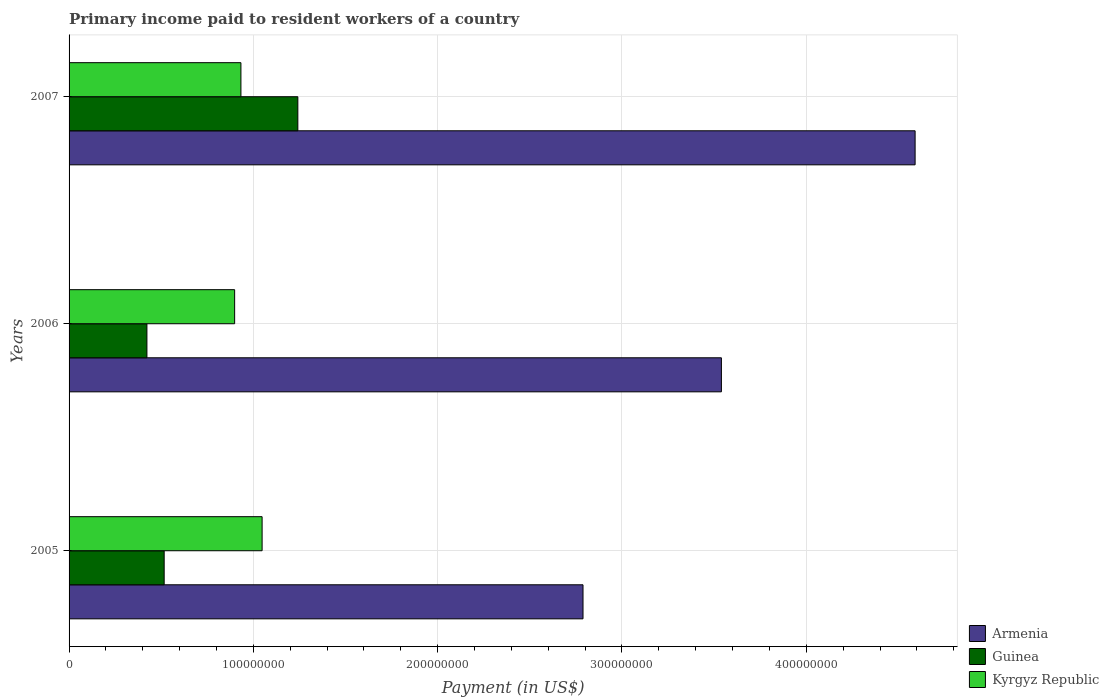How many groups of bars are there?
Offer a very short reply. 3. Are the number of bars per tick equal to the number of legend labels?
Give a very brief answer. Yes. Are the number of bars on each tick of the Y-axis equal?
Make the answer very short. Yes. How many bars are there on the 1st tick from the bottom?
Offer a very short reply. 3. In how many cases, is the number of bars for a given year not equal to the number of legend labels?
Provide a succinct answer. 0. What is the amount paid to workers in Guinea in 2005?
Offer a very short reply. 5.16e+07. Across all years, what is the maximum amount paid to workers in Armenia?
Offer a terse response. 4.59e+08. Across all years, what is the minimum amount paid to workers in Kyrgyz Republic?
Offer a very short reply. 8.98e+07. What is the total amount paid to workers in Guinea in the graph?
Offer a terse response. 2.18e+08. What is the difference between the amount paid to workers in Guinea in 2005 and that in 2006?
Offer a very short reply. 9.36e+06. What is the difference between the amount paid to workers in Armenia in 2006 and the amount paid to workers in Kyrgyz Republic in 2007?
Offer a terse response. 2.61e+08. What is the average amount paid to workers in Armenia per year?
Your response must be concise. 3.64e+08. In the year 2005, what is the difference between the amount paid to workers in Kyrgyz Republic and amount paid to workers in Armenia?
Your answer should be very brief. -1.74e+08. In how many years, is the amount paid to workers in Guinea greater than 160000000 US$?
Keep it short and to the point. 0. What is the ratio of the amount paid to workers in Guinea in 2005 to that in 2006?
Offer a very short reply. 1.22. Is the amount paid to workers in Kyrgyz Republic in 2005 less than that in 2006?
Keep it short and to the point. No. Is the difference between the amount paid to workers in Kyrgyz Republic in 2006 and 2007 greater than the difference between the amount paid to workers in Armenia in 2006 and 2007?
Offer a very short reply. Yes. What is the difference between the highest and the second highest amount paid to workers in Armenia?
Keep it short and to the point. 1.05e+08. What is the difference between the highest and the lowest amount paid to workers in Guinea?
Provide a short and direct response. 8.19e+07. Is the sum of the amount paid to workers in Armenia in 2005 and 2006 greater than the maximum amount paid to workers in Guinea across all years?
Offer a terse response. Yes. What does the 2nd bar from the top in 2007 represents?
Ensure brevity in your answer.  Guinea. What does the 1st bar from the bottom in 2005 represents?
Ensure brevity in your answer.  Armenia. Does the graph contain grids?
Offer a very short reply. Yes. What is the title of the graph?
Your answer should be very brief. Primary income paid to resident workers of a country. Does "Sierra Leone" appear as one of the legend labels in the graph?
Give a very brief answer. No. What is the label or title of the X-axis?
Provide a succinct answer. Payment (in US$). What is the label or title of the Y-axis?
Ensure brevity in your answer.  Years. What is the Payment (in US$) in Armenia in 2005?
Your answer should be very brief. 2.79e+08. What is the Payment (in US$) in Guinea in 2005?
Your response must be concise. 5.16e+07. What is the Payment (in US$) in Kyrgyz Republic in 2005?
Provide a succinct answer. 1.05e+08. What is the Payment (in US$) in Armenia in 2006?
Your answer should be compact. 3.54e+08. What is the Payment (in US$) of Guinea in 2006?
Offer a very short reply. 4.22e+07. What is the Payment (in US$) of Kyrgyz Republic in 2006?
Provide a short and direct response. 8.98e+07. What is the Payment (in US$) in Armenia in 2007?
Give a very brief answer. 4.59e+08. What is the Payment (in US$) in Guinea in 2007?
Your answer should be compact. 1.24e+08. What is the Payment (in US$) of Kyrgyz Republic in 2007?
Make the answer very short. 9.32e+07. Across all years, what is the maximum Payment (in US$) in Armenia?
Keep it short and to the point. 4.59e+08. Across all years, what is the maximum Payment (in US$) in Guinea?
Offer a terse response. 1.24e+08. Across all years, what is the maximum Payment (in US$) in Kyrgyz Republic?
Ensure brevity in your answer.  1.05e+08. Across all years, what is the minimum Payment (in US$) of Armenia?
Your answer should be compact. 2.79e+08. Across all years, what is the minimum Payment (in US$) of Guinea?
Your answer should be compact. 4.22e+07. Across all years, what is the minimum Payment (in US$) of Kyrgyz Republic?
Offer a terse response. 8.98e+07. What is the total Payment (in US$) in Armenia in the graph?
Keep it short and to the point. 1.09e+09. What is the total Payment (in US$) of Guinea in the graph?
Offer a terse response. 2.18e+08. What is the total Payment (in US$) in Kyrgyz Republic in the graph?
Offer a very short reply. 2.88e+08. What is the difference between the Payment (in US$) of Armenia in 2005 and that in 2006?
Your answer should be compact. -7.51e+07. What is the difference between the Payment (in US$) of Guinea in 2005 and that in 2006?
Give a very brief answer. 9.36e+06. What is the difference between the Payment (in US$) in Kyrgyz Republic in 2005 and that in 2006?
Give a very brief answer. 1.49e+07. What is the difference between the Payment (in US$) in Armenia in 2005 and that in 2007?
Provide a short and direct response. -1.80e+08. What is the difference between the Payment (in US$) of Guinea in 2005 and that in 2007?
Keep it short and to the point. -7.25e+07. What is the difference between the Payment (in US$) in Kyrgyz Republic in 2005 and that in 2007?
Keep it short and to the point. 1.15e+07. What is the difference between the Payment (in US$) of Armenia in 2006 and that in 2007?
Provide a succinct answer. -1.05e+08. What is the difference between the Payment (in US$) in Guinea in 2006 and that in 2007?
Offer a terse response. -8.19e+07. What is the difference between the Payment (in US$) in Kyrgyz Republic in 2006 and that in 2007?
Give a very brief answer. -3.41e+06. What is the difference between the Payment (in US$) in Armenia in 2005 and the Payment (in US$) in Guinea in 2006?
Your response must be concise. 2.37e+08. What is the difference between the Payment (in US$) of Armenia in 2005 and the Payment (in US$) of Kyrgyz Republic in 2006?
Keep it short and to the point. 1.89e+08. What is the difference between the Payment (in US$) in Guinea in 2005 and the Payment (in US$) in Kyrgyz Republic in 2006?
Your answer should be compact. -3.82e+07. What is the difference between the Payment (in US$) of Armenia in 2005 and the Payment (in US$) of Guinea in 2007?
Your answer should be compact. 1.55e+08. What is the difference between the Payment (in US$) of Armenia in 2005 and the Payment (in US$) of Kyrgyz Republic in 2007?
Make the answer very short. 1.86e+08. What is the difference between the Payment (in US$) of Guinea in 2005 and the Payment (in US$) of Kyrgyz Republic in 2007?
Offer a terse response. -4.16e+07. What is the difference between the Payment (in US$) of Armenia in 2006 and the Payment (in US$) of Guinea in 2007?
Keep it short and to the point. 2.30e+08. What is the difference between the Payment (in US$) of Armenia in 2006 and the Payment (in US$) of Kyrgyz Republic in 2007?
Ensure brevity in your answer.  2.61e+08. What is the difference between the Payment (in US$) of Guinea in 2006 and the Payment (in US$) of Kyrgyz Republic in 2007?
Give a very brief answer. -5.10e+07. What is the average Payment (in US$) of Armenia per year?
Give a very brief answer. 3.64e+08. What is the average Payment (in US$) in Guinea per year?
Give a very brief answer. 7.27e+07. What is the average Payment (in US$) in Kyrgyz Republic per year?
Your answer should be compact. 9.59e+07. In the year 2005, what is the difference between the Payment (in US$) of Armenia and Payment (in US$) of Guinea?
Provide a succinct answer. 2.27e+08. In the year 2005, what is the difference between the Payment (in US$) in Armenia and Payment (in US$) in Kyrgyz Republic?
Keep it short and to the point. 1.74e+08. In the year 2005, what is the difference between the Payment (in US$) in Guinea and Payment (in US$) in Kyrgyz Republic?
Offer a terse response. -5.31e+07. In the year 2006, what is the difference between the Payment (in US$) of Armenia and Payment (in US$) of Guinea?
Provide a succinct answer. 3.12e+08. In the year 2006, what is the difference between the Payment (in US$) of Armenia and Payment (in US$) of Kyrgyz Republic?
Offer a very short reply. 2.64e+08. In the year 2006, what is the difference between the Payment (in US$) of Guinea and Payment (in US$) of Kyrgyz Republic?
Provide a succinct answer. -4.76e+07. In the year 2007, what is the difference between the Payment (in US$) in Armenia and Payment (in US$) in Guinea?
Provide a short and direct response. 3.35e+08. In the year 2007, what is the difference between the Payment (in US$) of Armenia and Payment (in US$) of Kyrgyz Republic?
Your answer should be very brief. 3.66e+08. In the year 2007, what is the difference between the Payment (in US$) in Guinea and Payment (in US$) in Kyrgyz Republic?
Provide a short and direct response. 3.09e+07. What is the ratio of the Payment (in US$) of Armenia in 2005 to that in 2006?
Your answer should be very brief. 0.79. What is the ratio of the Payment (in US$) of Guinea in 2005 to that in 2006?
Provide a succinct answer. 1.22. What is the ratio of the Payment (in US$) in Kyrgyz Republic in 2005 to that in 2006?
Your response must be concise. 1.17. What is the ratio of the Payment (in US$) of Armenia in 2005 to that in 2007?
Provide a short and direct response. 0.61. What is the ratio of the Payment (in US$) in Guinea in 2005 to that in 2007?
Give a very brief answer. 0.42. What is the ratio of the Payment (in US$) of Kyrgyz Republic in 2005 to that in 2007?
Offer a terse response. 1.12. What is the ratio of the Payment (in US$) in Armenia in 2006 to that in 2007?
Keep it short and to the point. 0.77. What is the ratio of the Payment (in US$) of Guinea in 2006 to that in 2007?
Make the answer very short. 0.34. What is the ratio of the Payment (in US$) in Kyrgyz Republic in 2006 to that in 2007?
Give a very brief answer. 0.96. What is the difference between the highest and the second highest Payment (in US$) of Armenia?
Give a very brief answer. 1.05e+08. What is the difference between the highest and the second highest Payment (in US$) in Guinea?
Your answer should be very brief. 7.25e+07. What is the difference between the highest and the second highest Payment (in US$) of Kyrgyz Republic?
Provide a short and direct response. 1.15e+07. What is the difference between the highest and the lowest Payment (in US$) of Armenia?
Your answer should be compact. 1.80e+08. What is the difference between the highest and the lowest Payment (in US$) in Guinea?
Your response must be concise. 8.19e+07. What is the difference between the highest and the lowest Payment (in US$) of Kyrgyz Republic?
Ensure brevity in your answer.  1.49e+07. 